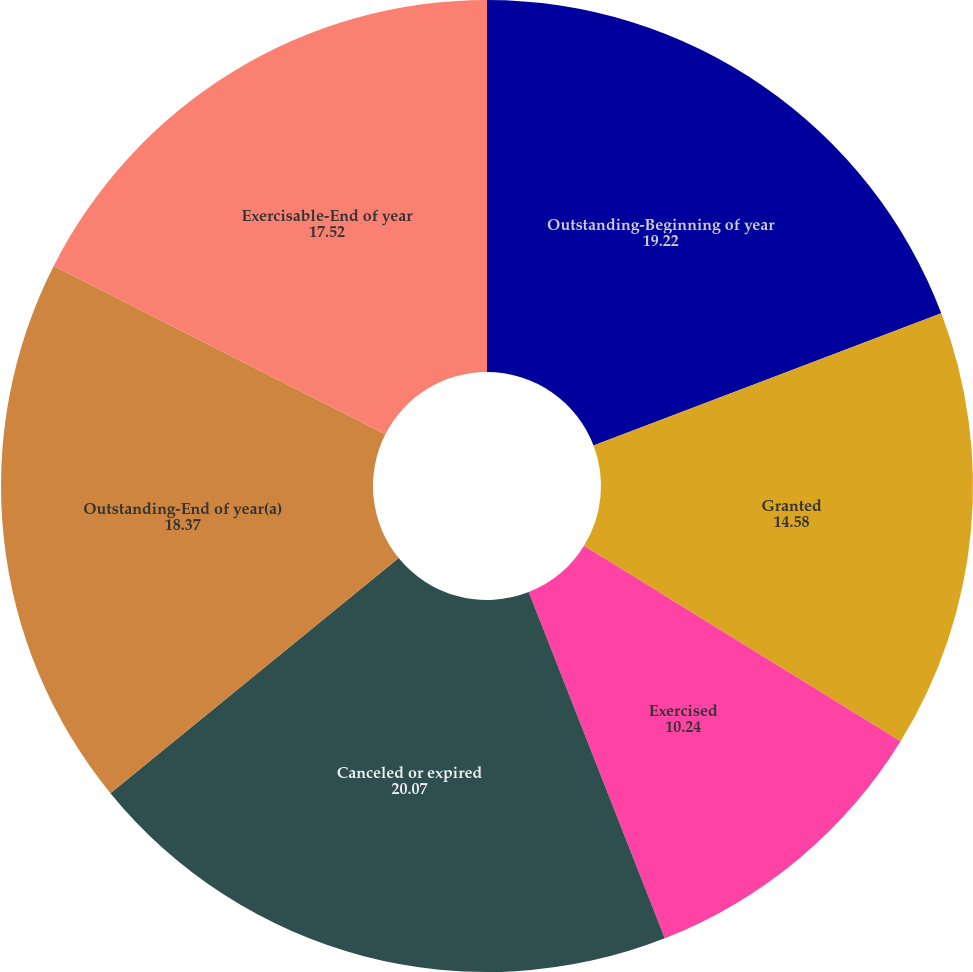Convert chart to OTSL. <chart><loc_0><loc_0><loc_500><loc_500><pie_chart><fcel>Outstanding-Beginning of year<fcel>Granted<fcel>Exercised<fcel>Canceled or expired<fcel>Outstanding-End of year(a)<fcel>Exercisable-End of year<nl><fcel>19.22%<fcel>14.58%<fcel>10.24%<fcel>20.07%<fcel>18.37%<fcel>17.52%<nl></chart> 